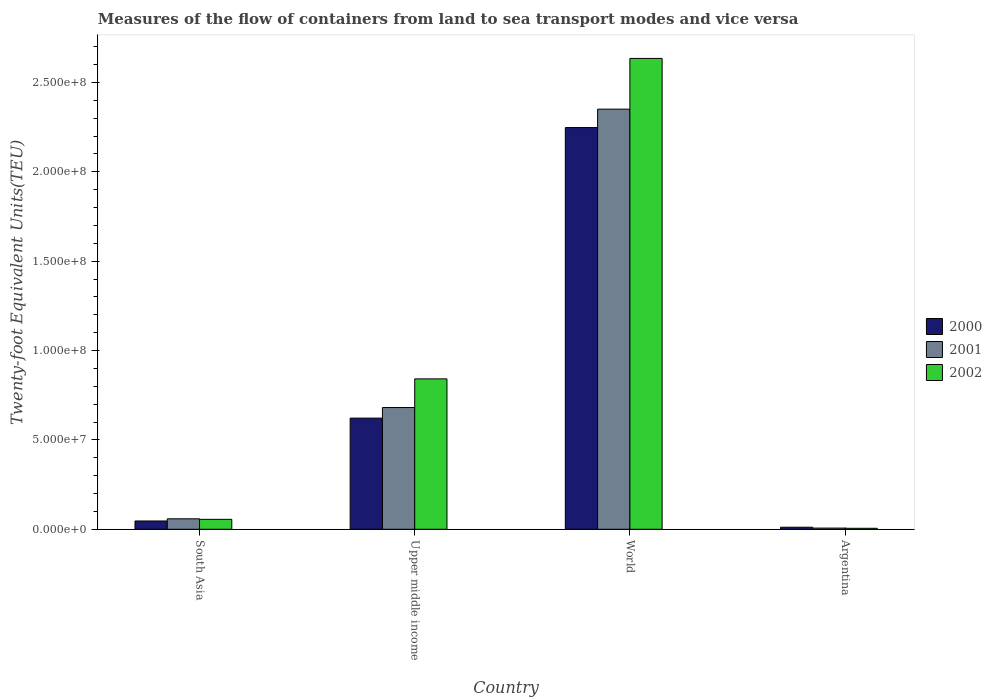How many groups of bars are there?
Offer a very short reply. 4. Are the number of bars per tick equal to the number of legend labels?
Your response must be concise. Yes. Are the number of bars on each tick of the X-axis equal?
Provide a succinct answer. Yes. How many bars are there on the 3rd tick from the right?
Offer a terse response. 3. What is the container port traffic in 2002 in World?
Provide a succinct answer. 2.63e+08. Across all countries, what is the maximum container port traffic in 2000?
Your answer should be very brief. 2.25e+08. Across all countries, what is the minimum container port traffic in 2001?
Make the answer very short. 6.64e+05. What is the total container port traffic in 2000 in the graph?
Keep it short and to the point. 2.93e+08. What is the difference between the container port traffic in 2001 in South Asia and that in Upper middle income?
Your answer should be compact. -6.23e+07. What is the difference between the container port traffic in 2000 in South Asia and the container port traffic in 2001 in Upper middle income?
Provide a succinct answer. -6.35e+07. What is the average container port traffic in 2001 per country?
Your answer should be very brief. 7.74e+07. What is the difference between the container port traffic of/in 2001 and container port traffic of/in 2000 in Argentina?
Make the answer very short. -4.81e+05. In how many countries, is the container port traffic in 2001 greater than 30000000 TEU?
Your answer should be very brief. 2. What is the ratio of the container port traffic in 2000 in South Asia to that in World?
Your response must be concise. 0.02. Is the difference between the container port traffic in 2001 in Upper middle income and World greater than the difference between the container port traffic in 2000 in Upper middle income and World?
Keep it short and to the point. No. What is the difference between the highest and the second highest container port traffic in 2002?
Provide a short and direct response. -7.86e+07. What is the difference between the highest and the lowest container port traffic in 2000?
Ensure brevity in your answer.  2.24e+08. What does the 2nd bar from the left in Upper middle income represents?
Give a very brief answer. 2001. Are all the bars in the graph horizontal?
Provide a succinct answer. No. How many countries are there in the graph?
Make the answer very short. 4. What is the difference between two consecutive major ticks on the Y-axis?
Your response must be concise. 5.00e+07. Are the values on the major ticks of Y-axis written in scientific E-notation?
Your response must be concise. Yes. Where does the legend appear in the graph?
Ensure brevity in your answer.  Center right. What is the title of the graph?
Give a very brief answer. Measures of the flow of containers from land to sea transport modes and vice versa. What is the label or title of the X-axis?
Offer a very short reply. Country. What is the label or title of the Y-axis?
Offer a terse response. Twenty-foot Equivalent Units(TEU). What is the Twenty-foot Equivalent Units(TEU) of 2000 in South Asia?
Ensure brevity in your answer.  4.64e+06. What is the Twenty-foot Equivalent Units(TEU) of 2001 in South Asia?
Offer a very short reply. 5.86e+06. What is the Twenty-foot Equivalent Units(TEU) of 2002 in South Asia?
Give a very brief answer. 5.56e+06. What is the Twenty-foot Equivalent Units(TEU) of 2000 in Upper middle income?
Make the answer very short. 6.22e+07. What is the Twenty-foot Equivalent Units(TEU) in 2001 in Upper middle income?
Offer a very short reply. 6.81e+07. What is the Twenty-foot Equivalent Units(TEU) in 2002 in Upper middle income?
Provide a succinct answer. 8.42e+07. What is the Twenty-foot Equivalent Units(TEU) in 2000 in World?
Provide a succinct answer. 2.25e+08. What is the Twenty-foot Equivalent Units(TEU) of 2001 in World?
Offer a very short reply. 2.35e+08. What is the Twenty-foot Equivalent Units(TEU) of 2002 in World?
Your answer should be very brief. 2.63e+08. What is the Twenty-foot Equivalent Units(TEU) in 2000 in Argentina?
Provide a succinct answer. 1.14e+06. What is the Twenty-foot Equivalent Units(TEU) in 2001 in Argentina?
Provide a short and direct response. 6.64e+05. What is the Twenty-foot Equivalent Units(TEU) in 2002 in Argentina?
Provide a succinct answer. 5.55e+05. Across all countries, what is the maximum Twenty-foot Equivalent Units(TEU) of 2000?
Keep it short and to the point. 2.25e+08. Across all countries, what is the maximum Twenty-foot Equivalent Units(TEU) in 2001?
Provide a short and direct response. 2.35e+08. Across all countries, what is the maximum Twenty-foot Equivalent Units(TEU) of 2002?
Ensure brevity in your answer.  2.63e+08. Across all countries, what is the minimum Twenty-foot Equivalent Units(TEU) of 2000?
Your answer should be very brief. 1.14e+06. Across all countries, what is the minimum Twenty-foot Equivalent Units(TEU) in 2001?
Provide a short and direct response. 6.64e+05. Across all countries, what is the minimum Twenty-foot Equivalent Units(TEU) in 2002?
Give a very brief answer. 5.55e+05. What is the total Twenty-foot Equivalent Units(TEU) of 2000 in the graph?
Provide a short and direct response. 2.93e+08. What is the total Twenty-foot Equivalent Units(TEU) in 2001 in the graph?
Offer a terse response. 3.10e+08. What is the total Twenty-foot Equivalent Units(TEU) in 2002 in the graph?
Keep it short and to the point. 3.54e+08. What is the difference between the Twenty-foot Equivalent Units(TEU) in 2000 in South Asia and that in Upper middle income?
Offer a very short reply. -5.76e+07. What is the difference between the Twenty-foot Equivalent Units(TEU) in 2001 in South Asia and that in Upper middle income?
Make the answer very short. -6.23e+07. What is the difference between the Twenty-foot Equivalent Units(TEU) in 2002 in South Asia and that in Upper middle income?
Offer a very short reply. -7.86e+07. What is the difference between the Twenty-foot Equivalent Units(TEU) in 2000 in South Asia and that in World?
Keep it short and to the point. -2.20e+08. What is the difference between the Twenty-foot Equivalent Units(TEU) in 2001 in South Asia and that in World?
Offer a terse response. -2.29e+08. What is the difference between the Twenty-foot Equivalent Units(TEU) in 2002 in South Asia and that in World?
Your answer should be very brief. -2.58e+08. What is the difference between the Twenty-foot Equivalent Units(TEU) in 2000 in South Asia and that in Argentina?
Provide a succinct answer. 3.49e+06. What is the difference between the Twenty-foot Equivalent Units(TEU) of 2001 in South Asia and that in Argentina?
Provide a short and direct response. 5.19e+06. What is the difference between the Twenty-foot Equivalent Units(TEU) in 2002 in South Asia and that in Argentina?
Your answer should be very brief. 5.00e+06. What is the difference between the Twenty-foot Equivalent Units(TEU) of 2000 in Upper middle income and that in World?
Keep it short and to the point. -1.63e+08. What is the difference between the Twenty-foot Equivalent Units(TEU) of 2001 in Upper middle income and that in World?
Provide a short and direct response. -1.67e+08. What is the difference between the Twenty-foot Equivalent Units(TEU) of 2002 in Upper middle income and that in World?
Your answer should be compact. -1.79e+08. What is the difference between the Twenty-foot Equivalent Units(TEU) of 2000 in Upper middle income and that in Argentina?
Keep it short and to the point. 6.11e+07. What is the difference between the Twenty-foot Equivalent Units(TEU) in 2001 in Upper middle income and that in Argentina?
Your answer should be compact. 6.75e+07. What is the difference between the Twenty-foot Equivalent Units(TEU) in 2002 in Upper middle income and that in Argentina?
Offer a terse response. 8.36e+07. What is the difference between the Twenty-foot Equivalent Units(TEU) in 2000 in World and that in Argentina?
Ensure brevity in your answer.  2.24e+08. What is the difference between the Twenty-foot Equivalent Units(TEU) in 2001 in World and that in Argentina?
Your answer should be compact. 2.34e+08. What is the difference between the Twenty-foot Equivalent Units(TEU) of 2002 in World and that in Argentina?
Keep it short and to the point. 2.63e+08. What is the difference between the Twenty-foot Equivalent Units(TEU) of 2000 in South Asia and the Twenty-foot Equivalent Units(TEU) of 2001 in Upper middle income?
Offer a very short reply. -6.35e+07. What is the difference between the Twenty-foot Equivalent Units(TEU) in 2000 in South Asia and the Twenty-foot Equivalent Units(TEU) in 2002 in Upper middle income?
Offer a very short reply. -7.95e+07. What is the difference between the Twenty-foot Equivalent Units(TEU) of 2001 in South Asia and the Twenty-foot Equivalent Units(TEU) of 2002 in Upper middle income?
Make the answer very short. -7.83e+07. What is the difference between the Twenty-foot Equivalent Units(TEU) of 2000 in South Asia and the Twenty-foot Equivalent Units(TEU) of 2001 in World?
Offer a very short reply. -2.30e+08. What is the difference between the Twenty-foot Equivalent Units(TEU) in 2000 in South Asia and the Twenty-foot Equivalent Units(TEU) in 2002 in World?
Your answer should be compact. -2.59e+08. What is the difference between the Twenty-foot Equivalent Units(TEU) of 2001 in South Asia and the Twenty-foot Equivalent Units(TEU) of 2002 in World?
Ensure brevity in your answer.  -2.58e+08. What is the difference between the Twenty-foot Equivalent Units(TEU) in 2000 in South Asia and the Twenty-foot Equivalent Units(TEU) in 2001 in Argentina?
Offer a terse response. 3.98e+06. What is the difference between the Twenty-foot Equivalent Units(TEU) of 2000 in South Asia and the Twenty-foot Equivalent Units(TEU) of 2002 in Argentina?
Your answer should be very brief. 4.08e+06. What is the difference between the Twenty-foot Equivalent Units(TEU) of 2001 in South Asia and the Twenty-foot Equivalent Units(TEU) of 2002 in Argentina?
Offer a terse response. 5.30e+06. What is the difference between the Twenty-foot Equivalent Units(TEU) of 2000 in Upper middle income and the Twenty-foot Equivalent Units(TEU) of 2001 in World?
Keep it short and to the point. -1.73e+08. What is the difference between the Twenty-foot Equivalent Units(TEU) of 2000 in Upper middle income and the Twenty-foot Equivalent Units(TEU) of 2002 in World?
Ensure brevity in your answer.  -2.01e+08. What is the difference between the Twenty-foot Equivalent Units(TEU) of 2001 in Upper middle income and the Twenty-foot Equivalent Units(TEU) of 2002 in World?
Offer a very short reply. -1.95e+08. What is the difference between the Twenty-foot Equivalent Units(TEU) of 2000 in Upper middle income and the Twenty-foot Equivalent Units(TEU) of 2001 in Argentina?
Provide a short and direct response. 6.15e+07. What is the difference between the Twenty-foot Equivalent Units(TEU) of 2000 in Upper middle income and the Twenty-foot Equivalent Units(TEU) of 2002 in Argentina?
Keep it short and to the point. 6.16e+07. What is the difference between the Twenty-foot Equivalent Units(TEU) in 2001 in Upper middle income and the Twenty-foot Equivalent Units(TEU) in 2002 in Argentina?
Provide a short and direct response. 6.76e+07. What is the difference between the Twenty-foot Equivalent Units(TEU) of 2000 in World and the Twenty-foot Equivalent Units(TEU) of 2001 in Argentina?
Your answer should be compact. 2.24e+08. What is the difference between the Twenty-foot Equivalent Units(TEU) in 2000 in World and the Twenty-foot Equivalent Units(TEU) in 2002 in Argentina?
Make the answer very short. 2.24e+08. What is the difference between the Twenty-foot Equivalent Units(TEU) of 2001 in World and the Twenty-foot Equivalent Units(TEU) of 2002 in Argentina?
Provide a succinct answer. 2.35e+08. What is the average Twenty-foot Equivalent Units(TEU) of 2000 per country?
Offer a terse response. 7.32e+07. What is the average Twenty-foot Equivalent Units(TEU) of 2001 per country?
Give a very brief answer. 7.74e+07. What is the average Twenty-foot Equivalent Units(TEU) in 2002 per country?
Your response must be concise. 8.84e+07. What is the difference between the Twenty-foot Equivalent Units(TEU) of 2000 and Twenty-foot Equivalent Units(TEU) of 2001 in South Asia?
Your answer should be compact. -1.22e+06. What is the difference between the Twenty-foot Equivalent Units(TEU) in 2000 and Twenty-foot Equivalent Units(TEU) in 2002 in South Asia?
Your response must be concise. -9.18e+05. What is the difference between the Twenty-foot Equivalent Units(TEU) in 2001 and Twenty-foot Equivalent Units(TEU) in 2002 in South Asia?
Make the answer very short. 2.99e+05. What is the difference between the Twenty-foot Equivalent Units(TEU) of 2000 and Twenty-foot Equivalent Units(TEU) of 2001 in Upper middle income?
Your response must be concise. -5.92e+06. What is the difference between the Twenty-foot Equivalent Units(TEU) of 2000 and Twenty-foot Equivalent Units(TEU) of 2002 in Upper middle income?
Provide a succinct answer. -2.20e+07. What is the difference between the Twenty-foot Equivalent Units(TEU) in 2001 and Twenty-foot Equivalent Units(TEU) in 2002 in Upper middle income?
Make the answer very short. -1.60e+07. What is the difference between the Twenty-foot Equivalent Units(TEU) of 2000 and Twenty-foot Equivalent Units(TEU) of 2001 in World?
Provide a succinct answer. -1.03e+07. What is the difference between the Twenty-foot Equivalent Units(TEU) in 2000 and Twenty-foot Equivalent Units(TEU) in 2002 in World?
Your answer should be compact. -3.87e+07. What is the difference between the Twenty-foot Equivalent Units(TEU) in 2001 and Twenty-foot Equivalent Units(TEU) in 2002 in World?
Offer a terse response. -2.84e+07. What is the difference between the Twenty-foot Equivalent Units(TEU) in 2000 and Twenty-foot Equivalent Units(TEU) in 2001 in Argentina?
Your response must be concise. 4.81e+05. What is the difference between the Twenty-foot Equivalent Units(TEU) of 2000 and Twenty-foot Equivalent Units(TEU) of 2002 in Argentina?
Your answer should be very brief. 5.90e+05. What is the difference between the Twenty-foot Equivalent Units(TEU) of 2001 and Twenty-foot Equivalent Units(TEU) of 2002 in Argentina?
Ensure brevity in your answer.  1.09e+05. What is the ratio of the Twenty-foot Equivalent Units(TEU) in 2000 in South Asia to that in Upper middle income?
Give a very brief answer. 0.07. What is the ratio of the Twenty-foot Equivalent Units(TEU) in 2001 in South Asia to that in Upper middle income?
Ensure brevity in your answer.  0.09. What is the ratio of the Twenty-foot Equivalent Units(TEU) in 2002 in South Asia to that in Upper middle income?
Your answer should be very brief. 0.07. What is the ratio of the Twenty-foot Equivalent Units(TEU) in 2000 in South Asia to that in World?
Your response must be concise. 0.02. What is the ratio of the Twenty-foot Equivalent Units(TEU) in 2001 in South Asia to that in World?
Your response must be concise. 0.02. What is the ratio of the Twenty-foot Equivalent Units(TEU) of 2002 in South Asia to that in World?
Your response must be concise. 0.02. What is the ratio of the Twenty-foot Equivalent Units(TEU) of 2000 in South Asia to that in Argentina?
Make the answer very short. 4.05. What is the ratio of the Twenty-foot Equivalent Units(TEU) in 2001 in South Asia to that in Argentina?
Your answer should be compact. 8.82. What is the ratio of the Twenty-foot Equivalent Units(TEU) in 2002 in South Asia to that in Argentina?
Your answer should be compact. 10.02. What is the ratio of the Twenty-foot Equivalent Units(TEU) of 2000 in Upper middle income to that in World?
Ensure brevity in your answer.  0.28. What is the ratio of the Twenty-foot Equivalent Units(TEU) of 2001 in Upper middle income to that in World?
Keep it short and to the point. 0.29. What is the ratio of the Twenty-foot Equivalent Units(TEU) of 2002 in Upper middle income to that in World?
Give a very brief answer. 0.32. What is the ratio of the Twenty-foot Equivalent Units(TEU) of 2000 in Upper middle income to that in Argentina?
Your answer should be compact. 54.33. What is the ratio of the Twenty-foot Equivalent Units(TEU) of 2001 in Upper middle income to that in Argentina?
Your answer should be compact. 102.62. What is the ratio of the Twenty-foot Equivalent Units(TEU) in 2002 in Upper middle income to that in Argentina?
Your answer should be very brief. 151.68. What is the ratio of the Twenty-foot Equivalent Units(TEU) of 2000 in World to that in Argentina?
Provide a short and direct response. 196.34. What is the ratio of the Twenty-foot Equivalent Units(TEU) in 2001 in World to that in Argentina?
Your answer should be compact. 354.13. What is the ratio of the Twenty-foot Equivalent Units(TEU) in 2002 in World to that in Argentina?
Give a very brief answer. 474.87. What is the difference between the highest and the second highest Twenty-foot Equivalent Units(TEU) of 2000?
Keep it short and to the point. 1.63e+08. What is the difference between the highest and the second highest Twenty-foot Equivalent Units(TEU) in 2001?
Provide a short and direct response. 1.67e+08. What is the difference between the highest and the second highest Twenty-foot Equivalent Units(TEU) in 2002?
Provide a succinct answer. 1.79e+08. What is the difference between the highest and the lowest Twenty-foot Equivalent Units(TEU) of 2000?
Provide a short and direct response. 2.24e+08. What is the difference between the highest and the lowest Twenty-foot Equivalent Units(TEU) in 2001?
Your answer should be compact. 2.34e+08. What is the difference between the highest and the lowest Twenty-foot Equivalent Units(TEU) in 2002?
Your response must be concise. 2.63e+08. 